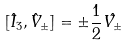<formula> <loc_0><loc_0><loc_500><loc_500>[ \hat { I } _ { 3 } , \hat { V } _ { \pm } ] = \pm \frac { 1 } { 2 } \hat { V _ { \pm } }</formula> 